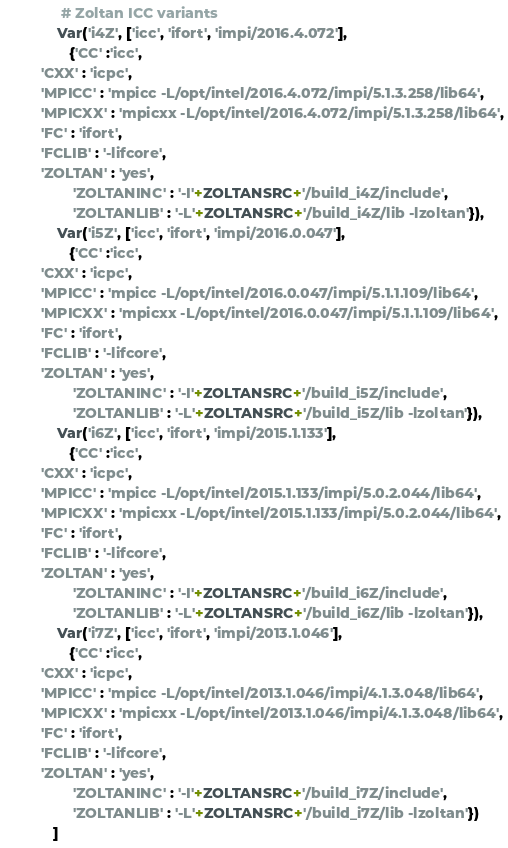<code> <loc_0><loc_0><loc_500><loc_500><_Python_>              # Zoltan ICC variants
             Var('i4Z', ['icc', 'ifort', 'impi/2016.4.072'],
                {'CC' :'icc',
		 'CXX' : 'icpc',
		 'MPICC' : 'mpicc -L/opt/intel/2016.4.072/impi/5.1.3.258/lib64',
		 'MPICXX' : 'mpicxx -L/opt/intel/2016.4.072/impi/5.1.3.258/lib64',
		 'FC' : 'ifort',
		 'FCLIB' : '-lifcore',
		 'ZOLTAN' : 'yes',
                 'ZOLTANINC' : '-I'+ZOLTANSRC+'/build_i4Z/include',
                 'ZOLTANLIB' : '-L'+ZOLTANSRC+'/build_i4Z/lib -lzoltan'}),
             Var('i5Z', ['icc', 'ifort', 'impi/2016.0.047'],
                {'CC' :'icc',
		 'CXX' : 'icpc',
		 'MPICC' : 'mpicc -L/opt/intel/2016.0.047/impi/5.1.1.109/lib64',
		 'MPICXX' : 'mpicxx -L/opt/intel/2016.0.047/impi/5.1.1.109/lib64',
		 'FC' : 'ifort',
		 'FCLIB' : '-lifcore',
		 'ZOLTAN' : 'yes',
                 'ZOLTANINC' : '-I'+ZOLTANSRC+'/build_i5Z/include',
                 'ZOLTANLIB' : '-L'+ZOLTANSRC+'/build_i5Z/lib -lzoltan'}),
             Var('i6Z', ['icc', 'ifort', 'impi/2015.1.133'],
                {'CC' :'icc',
		 'CXX' : 'icpc',
		 'MPICC' : 'mpicc -L/opt/intel/2015.1.133/impi/5.0.2.044/lib64',
		 'MPICXX' : 'mpicxx -L/opt/intel/2015.1.133/impi/5.0.2.044/lib64',
		 'FC' : 'ifort',
		 'FCLIB' : '-lifcore',
		 'ZOLTAN' : 'yes',
                 'ZOLTANINC' : '-I'+ZOLTANSRC+'/build_i6Z/include',
                 'ZOLTANLIB' : '-L'+ZOLTANSRC+'/build_i6Z/lib -lzoltan'}),
             Var('i7Z', ['icc', 'ifort', 'impi/2013.1.046'],
                {'CC' :'icc',
		 'CXX' : 'icpc',
		 'MPICC' : 'mpicc -L/opt/intel/2013.1.046/impi/4.1.3.048/lib64',
		 'MPICXX' : 'mpicxx -L/opt/intel/2013.1.046/impi/4.1.3.048/lib64',
		 'FC' : 'ifort',
		 'FCLIB' : '-lifcore',
		 'ZOLTAN' : 'yes',
                 'ZOLTANINC' : '-I'+ZOLTANSRC+'/build_i7Z/include',
                 'ZOLTANLIB' : '-L'+ZOLTANSRC+'/build_i7Z/lib -lzoltan'})
            ]
</code> 